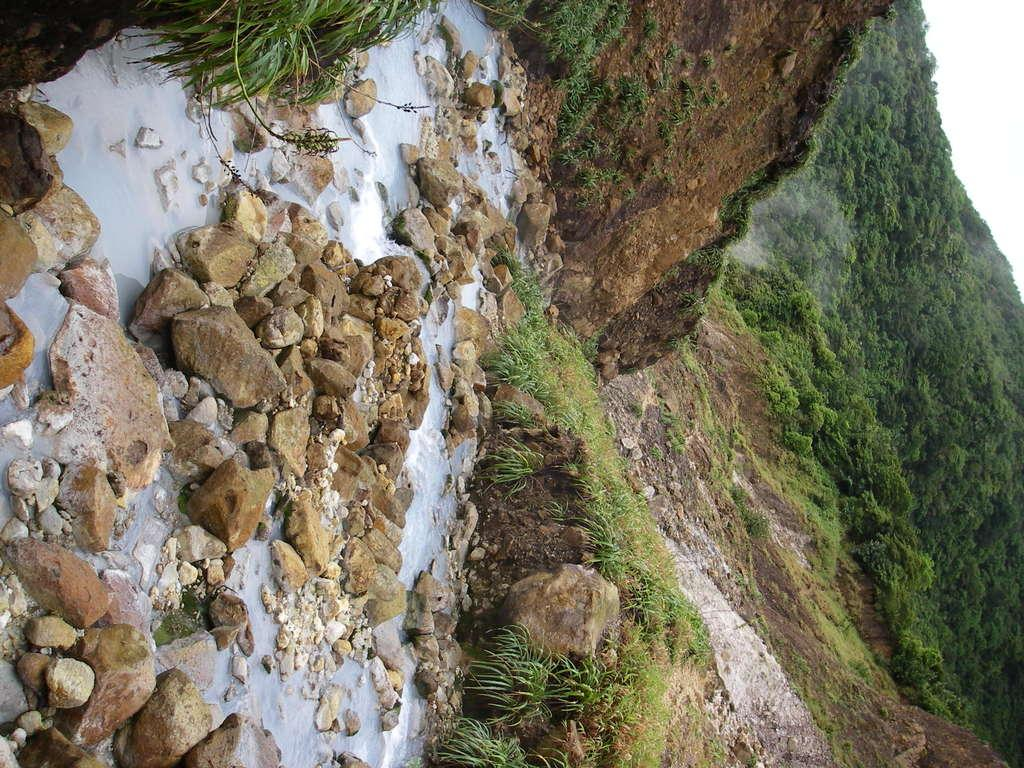What is located on the left side of the image? There is water on the left side of the image. What is near the water in the image? There are stones near the water. What can be seen in the background of the image? There are mountains, trees, grass, and the sky visible in the background of the image. How many dimes are scattered among the stones near the water in the image? There are no dimes present in the image; it features water, stones, mountains, trees, grass, and the sky. What type of trouble can be seen in the image? There is no trouble depicted in the image; it is a serene scene with water, stones, mountains, trees, grass, and the sky. 